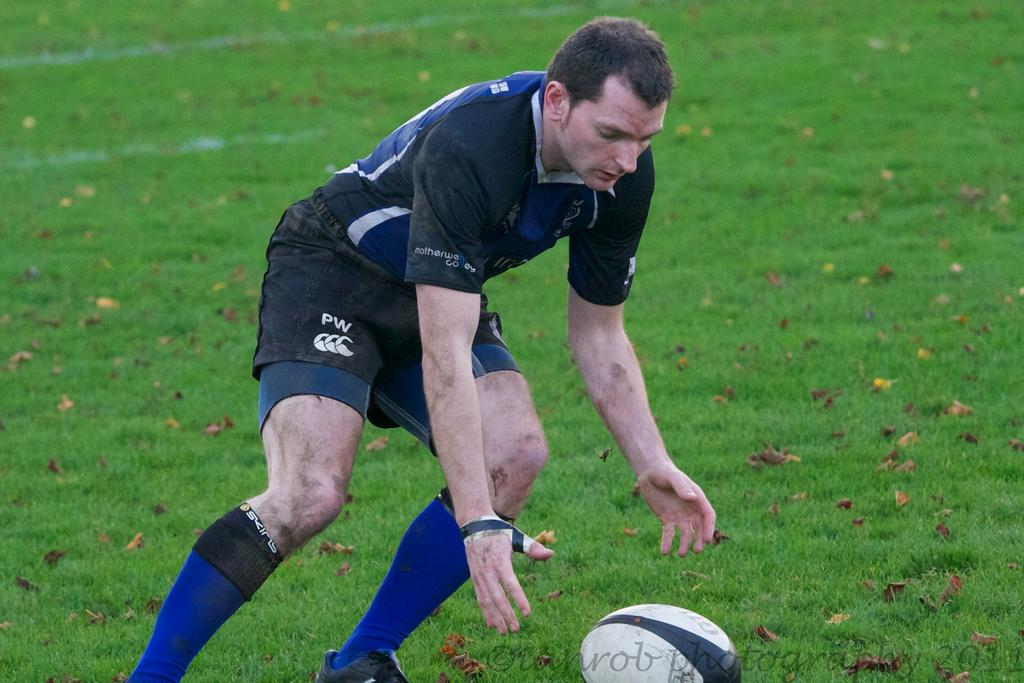What is the main subject of the image? There is a person standing in the image. What is the person's position in relation to the ground? The person is standing on the ground. What other object can be seen in the image? There is a ball visible in the image. What type of skin is visible on the giants in the image? There are no giants present in the image, so there is no skin to observe. 